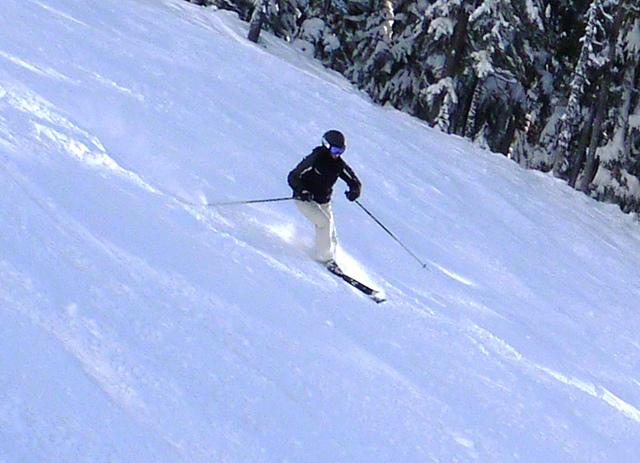Is it Winter?
Answer briefly. Yes. What is the boy wearing over his eyes?
Short answer required. Goggles. What is on the ground?
Write a very short answer. Snow. 